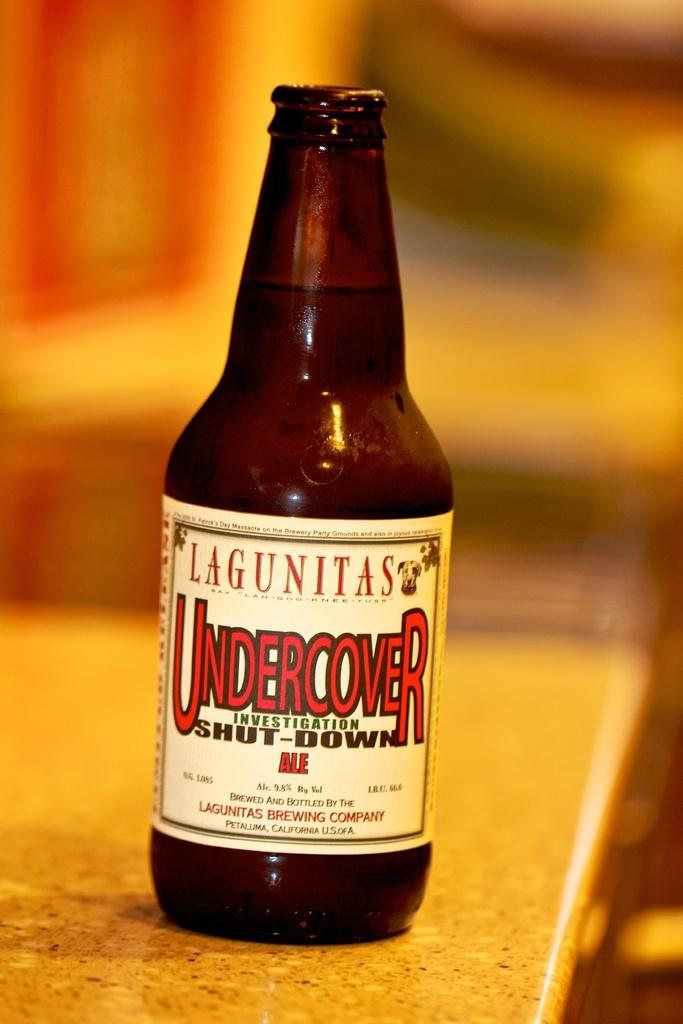<image>
Render a clear and concise summary of the photo. A bottle of Lagunitas Undercover Investigation Shut Down Ale. 